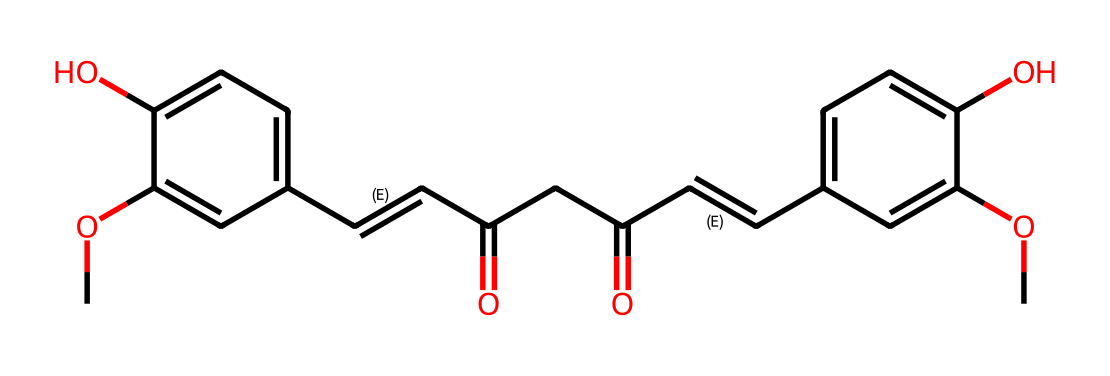What is the main functional group present in curcumin? The structure shows a hydroxyl group (-OH) and a carbonyl group (C=O), which are indicative of phenolic and ketone functional groups. However, the dominant functional group here is the phenolic (-OH) due to its prevalence in the structure.
Answer: phenolic How many rings are in the curcumin structure? Analyzing the structure, there are two aromatic rings connected by a carbon chain. This indicates the presence of two distinct ring structures in the molecule.
Answer: two What type of chemical is curcumin classified as? Curcumin belongs to the class of polyphenols, which can act as antioxidants, based on the multiple aromatic rings and hydroxyl groups present.
Answer: polyphenol What is the total number of carbon atoms in curcumin? Counting the carbon atoms from the SMILES representation, there are 21 carbon atoms present in the entire molecular structure of curcumin.
Answer: 21 What does the presence of multiple hydroxyl groups in curcumin suggest about its antioxidant properties? Multiple hydroxyl groups can donate hydrogen atoms and scavenge free radicals, indicating that curcumin possesses strong antioxidant capabilities because it can effectively neutralize reactive oxygen species.
Answer: strong 